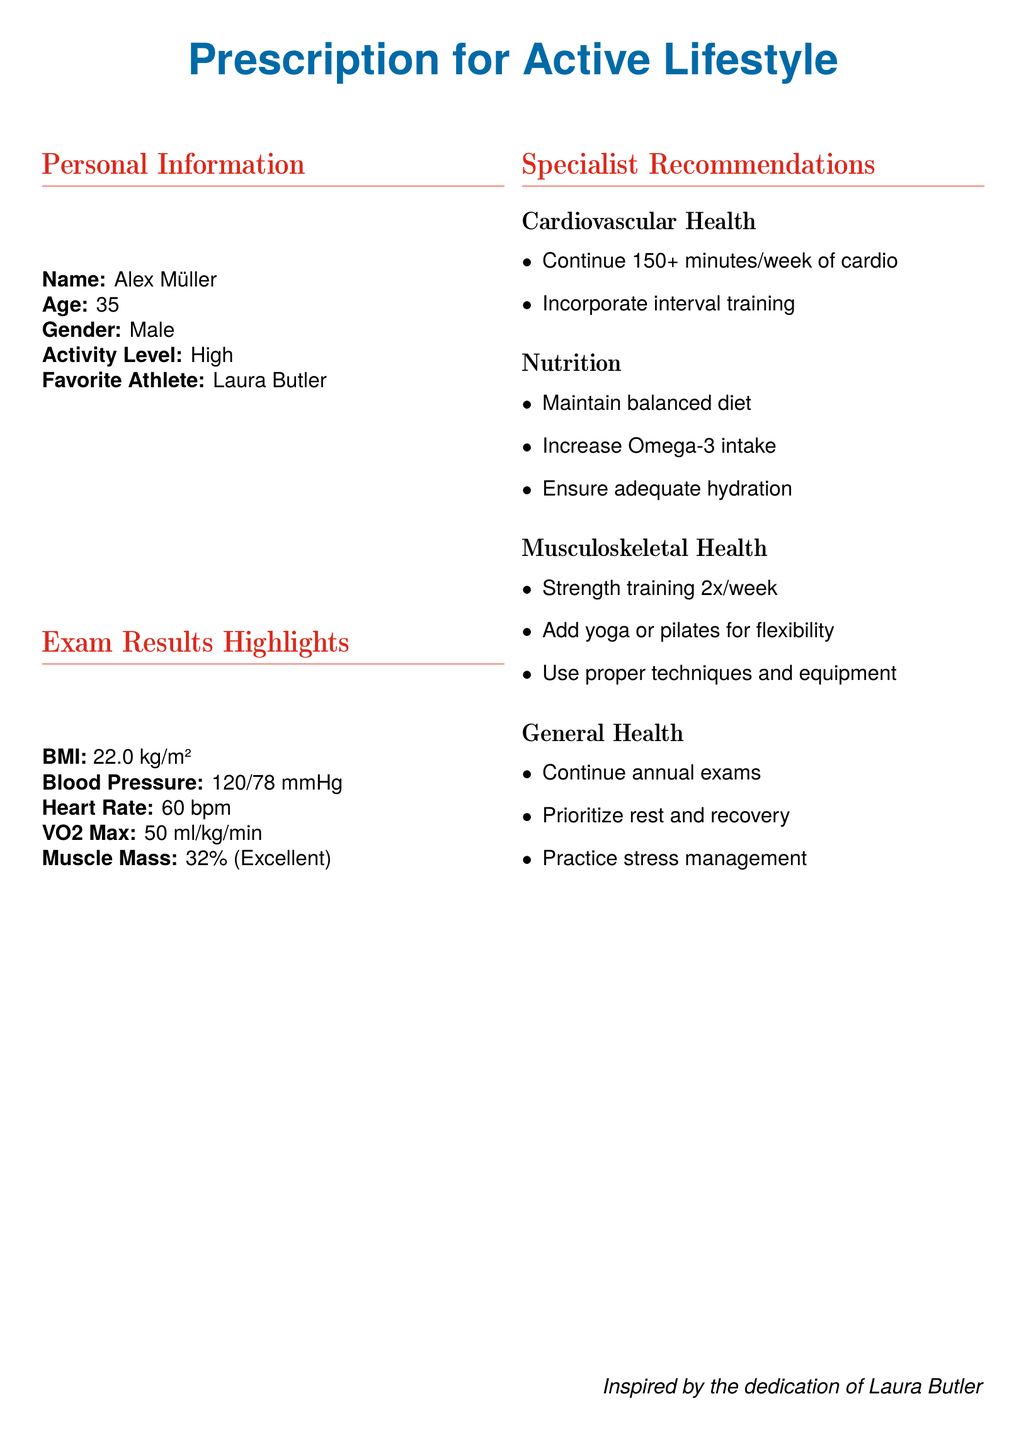What is the name of the individual in the document? The individual's name is mentioned in the personal information section.
Answer: Alex Müller What is the age of Alex Müller? The age of Alex Müller is specified in the personal information section.
Answer: 35 What is Alex Müller's BMI? The BMI value is provided in the exam results highlights.
Answer: 22.0 kg/m² What is the recommended weekly duration of cardio exercise? The recommendation for cardio is stated in the specialist recommendations section.
Answer: 150+ minutes/week How many times a week should strength training be performed? The frequency for strength training is specified in the musculoskeletal health recommendations.
Answer: 2x/week What should be increased in the diet according to the nutrition recommendations? The specific dietary suggestion related to Omega is found in the nutrition section.
Answer: Omega-3 intake What is the average heart rate of Alex Müller? The heart rate is included in the exam results highlights.
Answer: 60 bpm What is one of the general health recommendations? The document lists various general health recommendations.
Answer: Continue annual exams Which athlete inspires Alex Müller? The favorite athlete is stated in the personal information section.
Answer: Laura Butler 